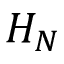Convert formula to latex. <formula><loc_0><loc_0><loc_500><loc_500>H _ { N }</formula> 